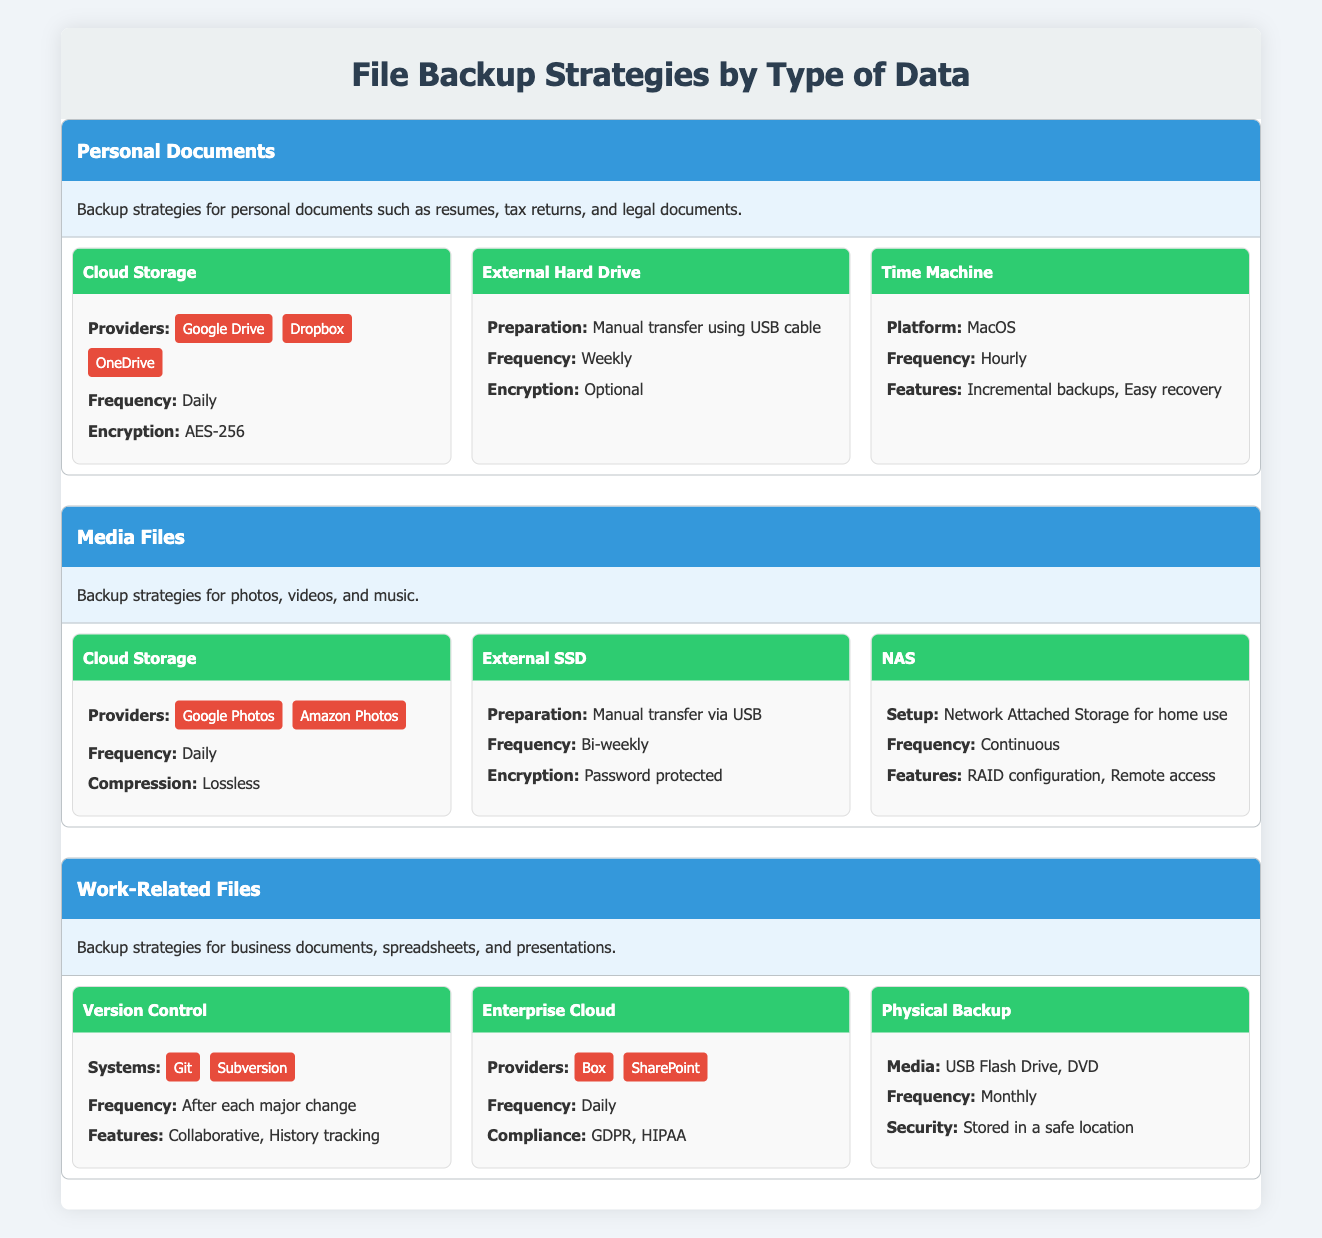What is the frequency of backups for personal documents using Cloud Storage? The table states that Cloud Storage for personal documents has a frequency of "Daily." This information is found directly in the methods section under Personal Documents.
Answer: Daily What types of encryption are mentioned for the External Hard Drive backup method? The External Hard Drive method for personal documents mentions that encryption is "Optional." Therefore, only one type (optional) is indicated, and it does not specify a particular encryption standard.
Answer: Optional Do media files utilize lossless compression in backup methods? Yes, the table explicitly mentions that the Cloud Storage method for Media Files specifies "Lossless" as the type of compression used. Thus, the claim is true based on the provided information.
Answer: Yes Which backup method for work-related files is compliant with GDPR? The Enterprise Cloud method under Work-Related Files specifies compliance with "GDPR," indicated in the compliance section. This means that this method meets the required data protection regulations.
Answer: Enterprise Cloud What is the frequency of backups for Media Files using NAS? The NAS method for Media Files states that the frequency is "Continuous." This means that backups using NAS occur without interruption, based on the information in the methods section for Media Files.
Answer: Continuous How many different backup methods are listed for personal documents? The Personal Documents section outlines three backup methods: Cloud Storage, External Hard Drive, and Time Machine. Thus, when counting them, we find that there are a total of three methods listed.
Answer: 3 Is the Time Machine backup method available on Windows platforms? The table indicates that the Time Machine backup method is specifically for "MacOS," which implies it is not available for Windows. Therefore, the answer is no.
Answer: No What is the preparation method for External SSD backups? The table specifies that the preparation for External SSD backup is "Manual transfer via USB." This indicates the method used to perform the backups for this type of data.
Answer: Manual transfer via USB Which backup methods have a frequency of "Weekly" or less frequent? From the table, the External Hard Drive method has a frequency of "Weekly," and the Physical Backup method has a frequency of "Monthly." Both are less frequent than daily, fulfilling the criteria. There are two methods that meet this condition.
Answer: 2 